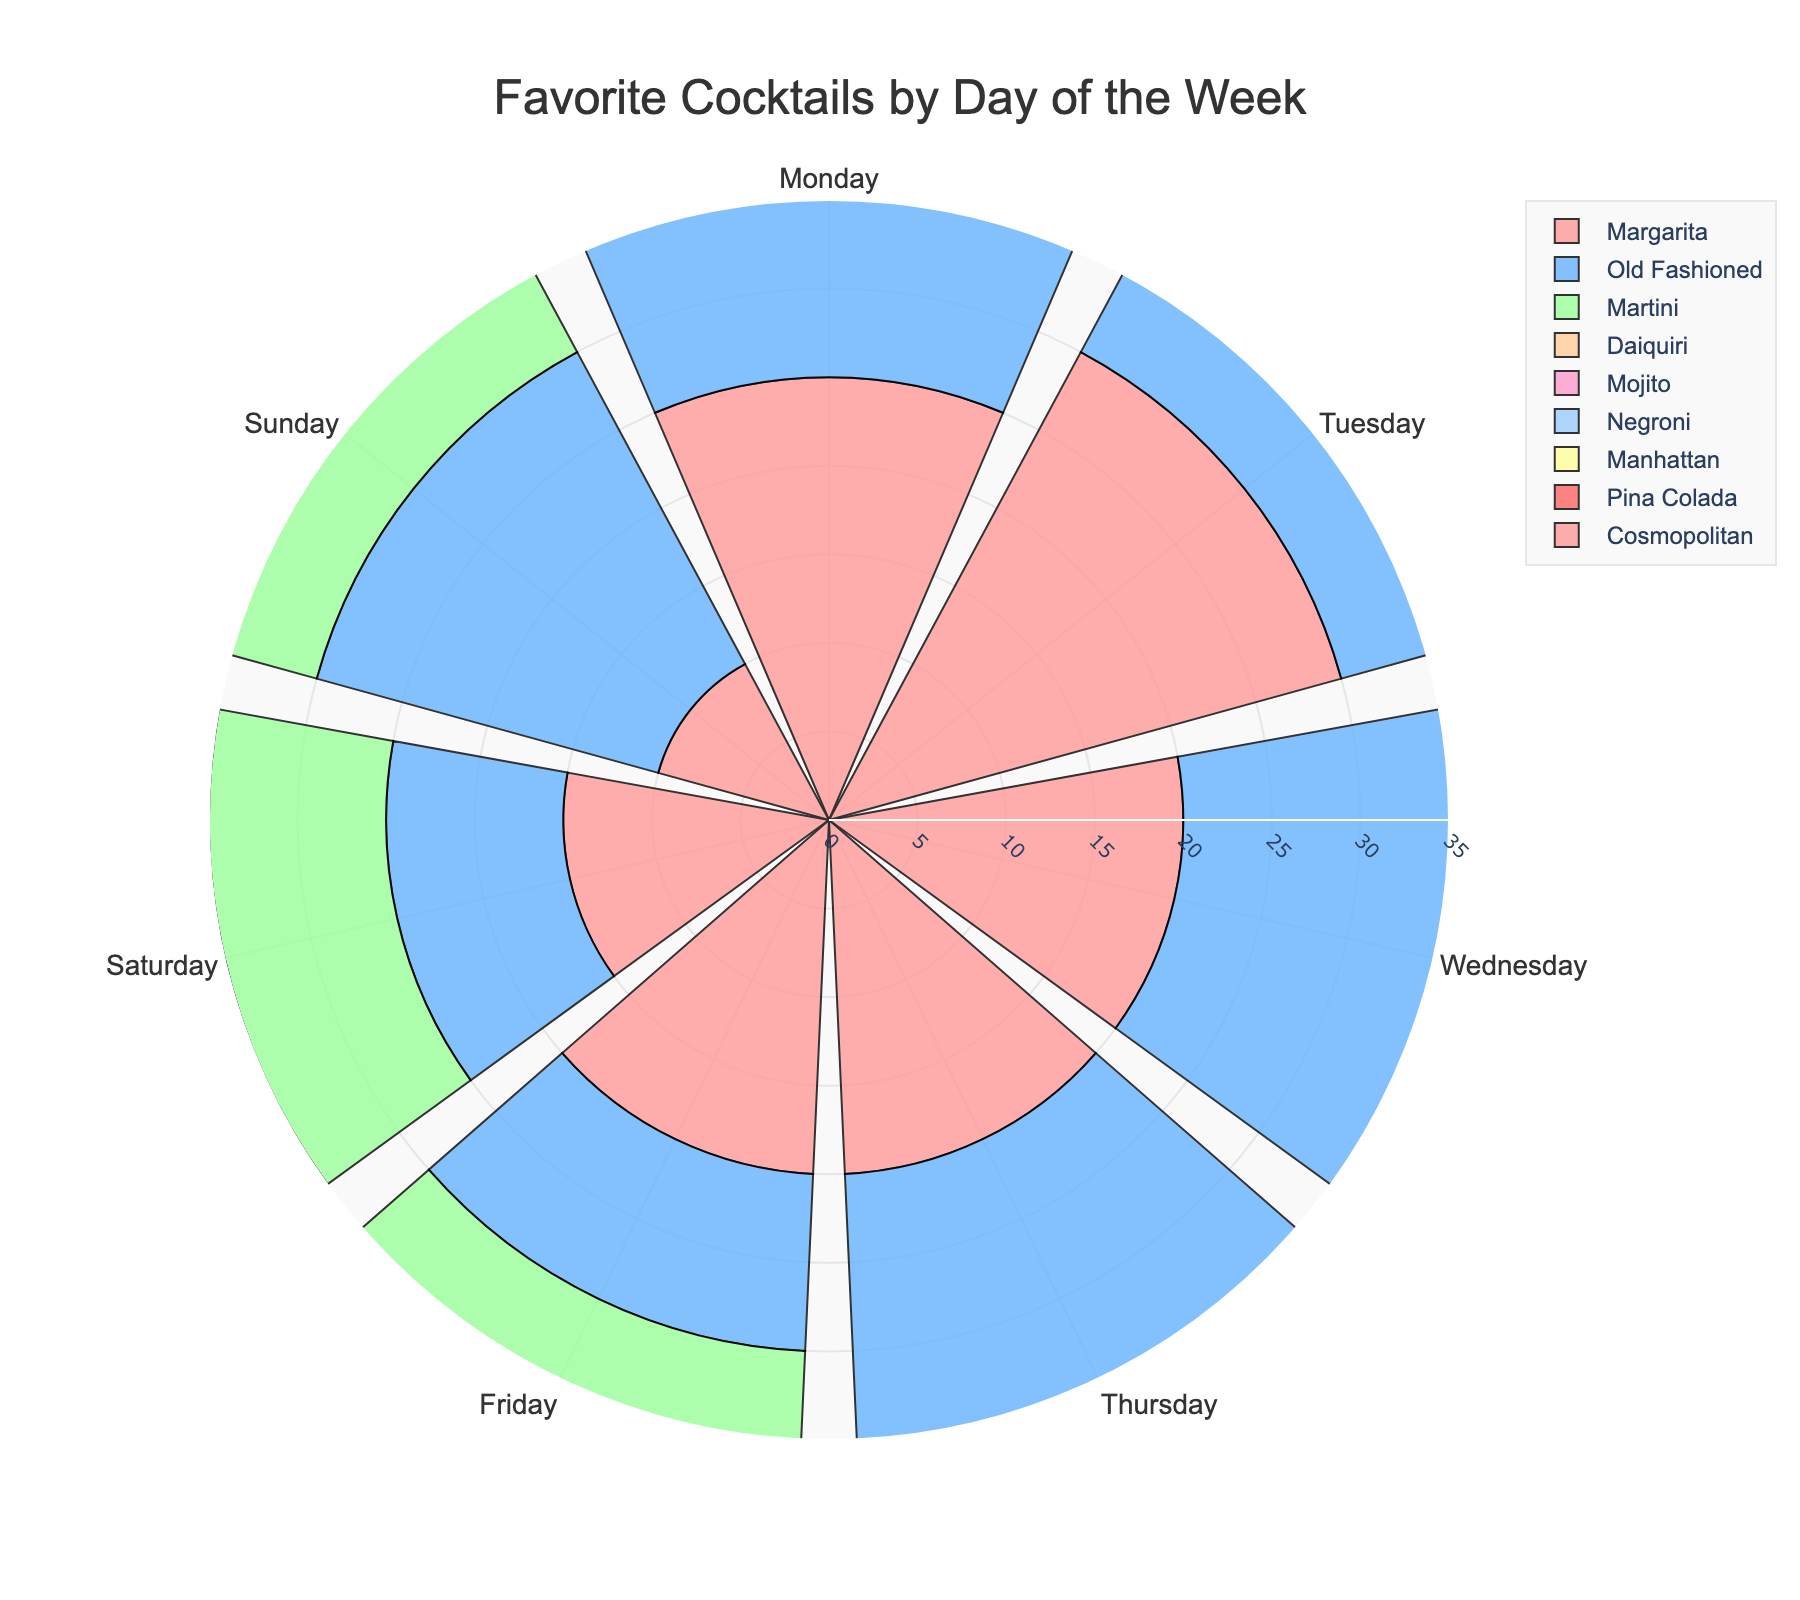What's the title of the figure? The title of a figure is usually placed at the top and is formatted in a larger or bolder font for emphasis. In this case, it is centered and reads "Favorite Cocktails by Day of the Week.".
Answer: Favorite Cocktails by Day of the Week Which cocktail is most popular on Mondays? To determine the most popular cocktail on Monday, we look for the one with the highest percentage on Monday. Margarita, with 25%, is the largest segment for Monday.
Answer: Margarita On which day is the Old Fashioned most popular? By checking the segments for Old Fashioned on each day, we can see that Thursday has the largest percentage (30%).
Answer: Thursday Compare the popularity of Margaritas on Tuesdays and Fridays. We need to check the percentage values for Margaritas on both days. Tuesday has 30% and Friday has 20%, making it more popular on Tuesday.
Answer: Tuesday What is the least ordered cocktail on Saturday? Look for the cocktail with the smallest percentage on Saturday. Manhattan, at 5%, is the least ordered.
Answer: Manhattan Which day has the highest variety of cocktails ordered? The variety of cocktails can be inferred by the number of different cocktails listed for each day. Saturday has the highest variety with seven different cocktails.
Answer: Saturday On which day is the Pina Colada the most popular? By going through the segments for Pina Colada, Sunday has the highest percentage (25%).
Answer: Sunday What is the average percentage of the Margaritas ordered across all days? Add the percentages for Margarita across all days: 25 + 30 + 20 + 20 + 20 + 15 + 10 =140. There are 7 days, so 140/7 = 20.
Answer: 20 Which cocktail is not ordered on Wednesday? By checking the entries for Wednesday, Manhattan is the one not listed.
Answer: Manhattan What's the combined percentage of Daiquiris ordered on both Monday and Thursday? Add the percentages for Daiquiris on Monday and Thursday: 15 + 10 = 25.
Answer: 25 